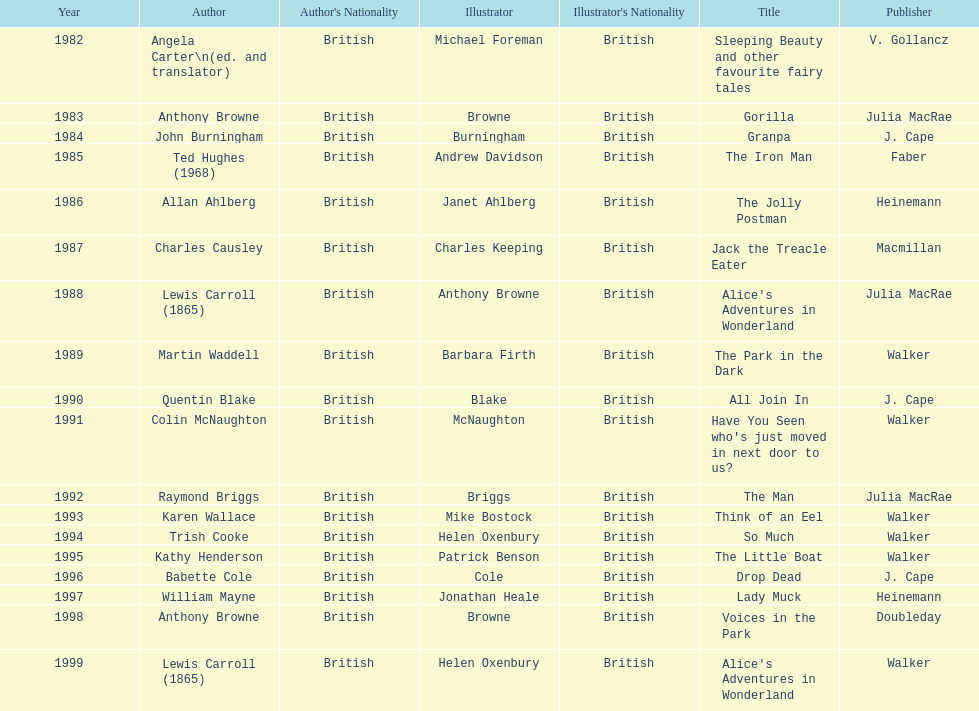What is the only title listed for 1999? Alice's Adventures in Wonderland. 